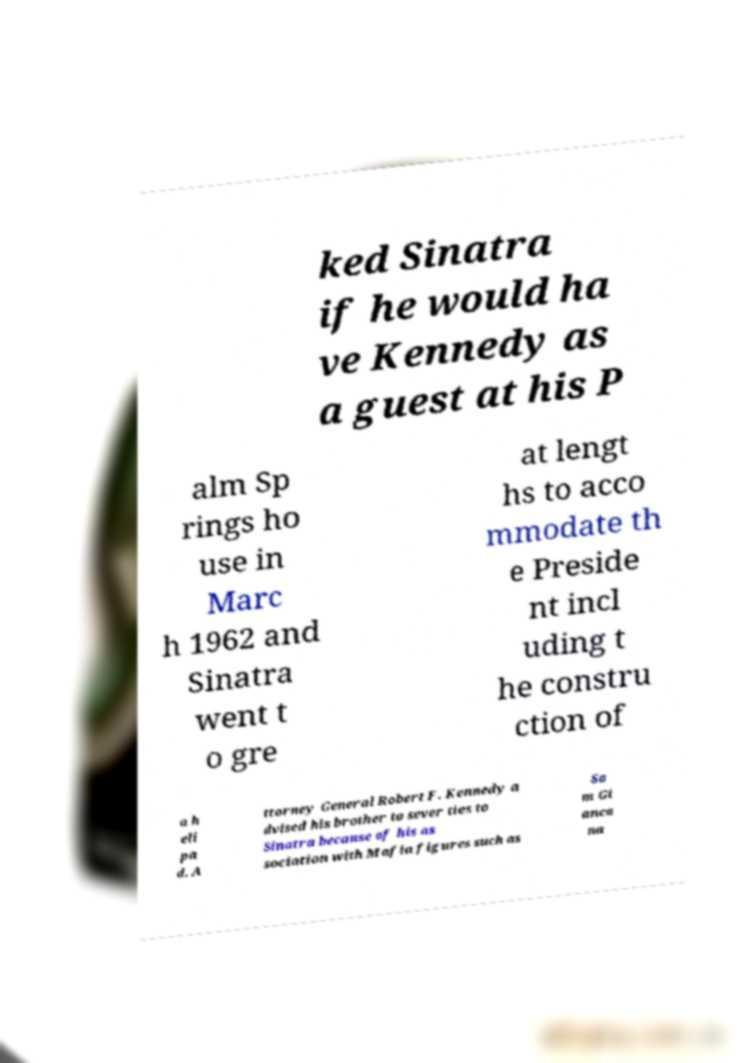There's text embedded in this image that I need extracted. Can you transcribe it verbatim? ked Sinatra if he would ha ve Kennedy as a guest at his P alm Sp rings ho use in Marc h 1962 and Sinatra went t o gre at lengt hs to acco mmodate th e Preside nt incl uding t he constru ction of a h eli pa d. A ttorney General Robert F. Kennedy a dvised his brother to sever ties to Sinatra because of his as sociation with Mafia figures such as Sa m Gi anca na 